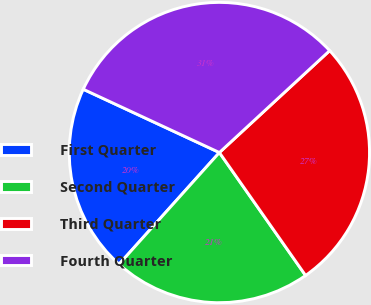Convert chart. <chart><loc_0><loc_0><loc_500><loc_500><pie_chart><fcel>First Quarter<fcel>Second Quarter<fcel>Third Quarter<fcel>Fourth Quarter<nl><fcel>20.28%<fcel>21.38%<fcel>27.14%<fcel>31.2%<nl></chart> 